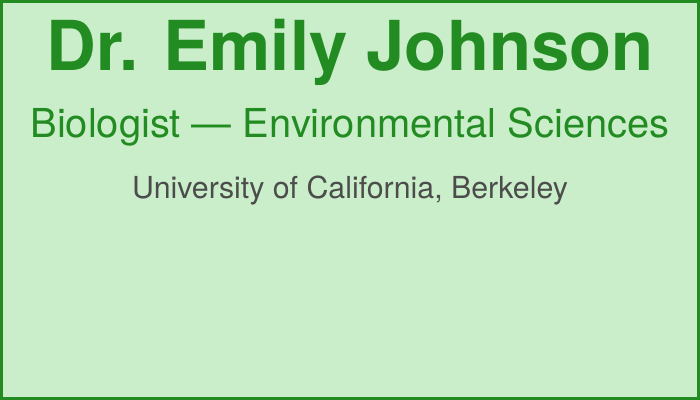What is the name of the biologist? The name is prominently displayed at the top of the document.
Answer: Dr. Emily Johnson What is the affiliation of Dr. Emily Johnson? The affiliation is provided below the title and includes the university's name.
Answer: University of California, Berkeley What is the contact email listed on the card? The email is shown in the contact information section.
Answer: emily.johnson@berkeley.edu What is Dr. Emily Johnson's specialization? This information is provided in a descriptive line towards the bottom of the document.
Answer: Environmental impacts on animal skin health What is the phone number provided? The phone number is listed alongside the email and address in the contact section.
Answer: +1-510-643-1234 What color is used for the background of the card? This can be inferred from the overall design of the card.
Answer: Light green What type of document is this? The structure and purpose indicate the type of document.
Answer: Business card How can I access Dr. Emily Johnson's LinkedIn profile? This method of access is given through the QR code on the card.
Answer: QR code What is the address for Dr. Emily Johnson? The address is shown in the contact information area.
Answer: 2101 Valley Life Sciences Building, Berkeley, CA 94720 